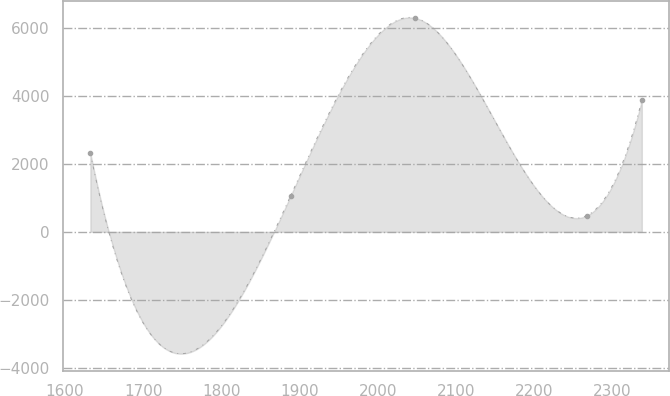<chart> <loc_0><loc_0><loc_500><loc_500><line_chart><ecel><fcel>Unnamed: 1<nl><fcel>1632.41<fcel>2310.46<nl><fcel>1888.48<fcel>1057.04<nl><fcel>2048.14<fcel>6282.23<nl><fcel>2267.2<fcel>476.46<nl><fcel>2337.63<fcel>3865.09<nl></chart> 